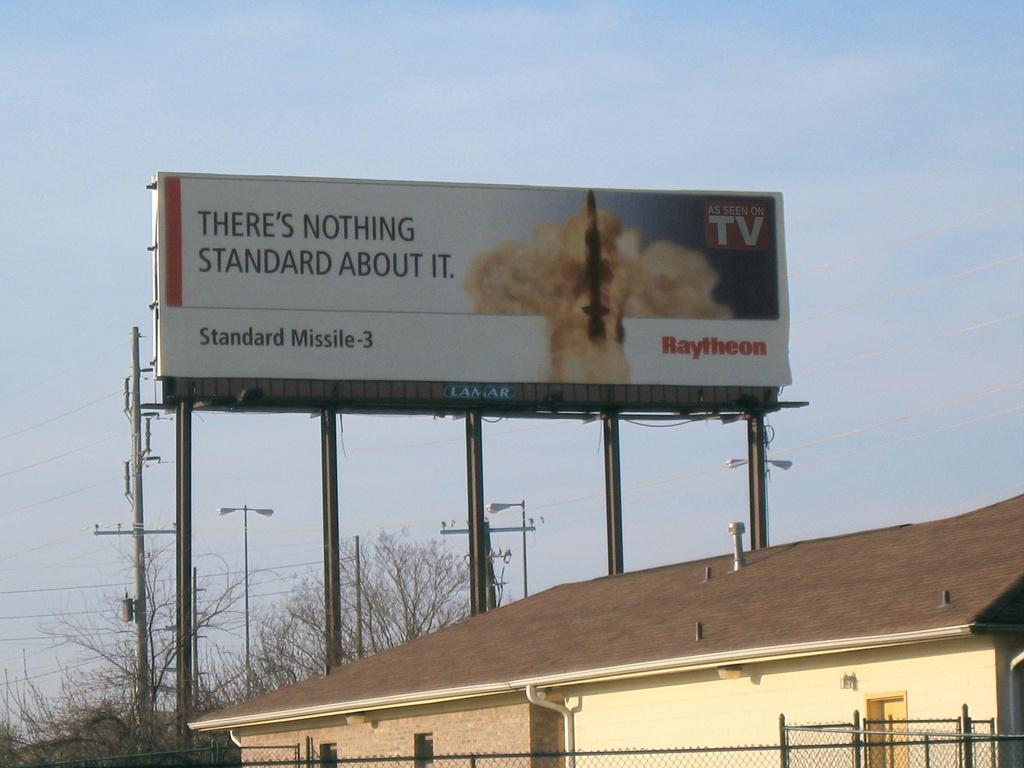Does raytheon build bombs?
Offer a very short reply. No. 